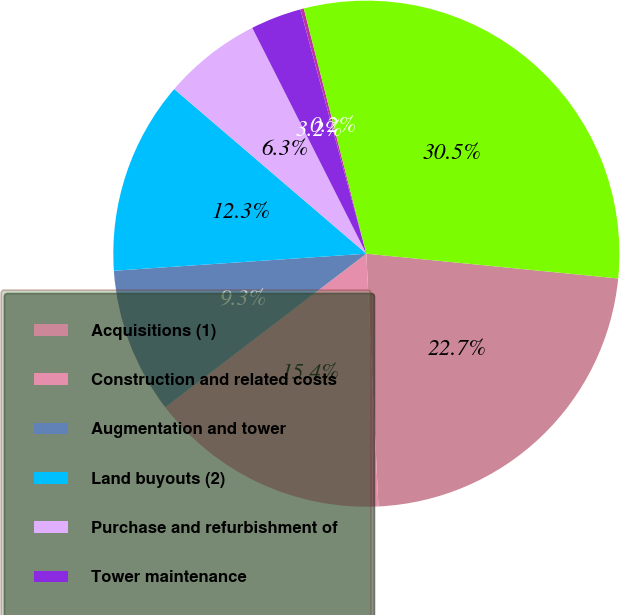Convert chart. <chart><loc_0><loc_0><loc_500><loc_500><pie_chart><fcel>Acquisitions (1)<fcel>Construction and related costs<fcel>Augmentation and tower<fcel>Land buyouts (2)<fcel>Purchase and refurbishment of<fcel>Tower maintenance<fcel>General corporate<fcel>Total cash capital<nl><fcel>22.68%<fcel>15.38%<fcel>9.31%<fcel>12.35%<fcel>6.28%<fcel>3.25%<fcel>0.22%<fcel>30.54%<nl></chart> 